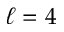<formula> <loc_0><loc_0><loc_500><loc_500>\ell = 4</formula> 